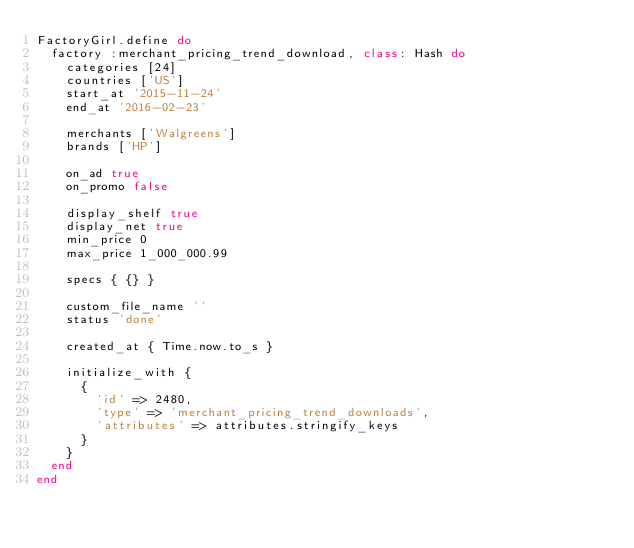Convert code to text. <code><loc_0><loc_0><loc_500><loc_500><_Ruby_>FactoryGirl.define do
  factory :merchant_pricing_trend_download, class: Hash do
    categories [24]
    countries ['US']
    start_at '2015-11-24'
    end_at '2016-02-23'

    merchants ['Walgreens']
    brands ['HP']

    on_ad true
    on_promo false

    display_shelf true
    display_net true
    min_price 0
    max_price 1_000_000.99

    specs { {} }

    custom_file_name ''
    status 'done'

    created_at { Time.now.to_s }

    initialize_with {
      {
        'id' => 2480,
        'type' => 'merchant_pricing_trend_downloads',
        'attributes' => attributes.stringify_keys
      }
    }
  end
end
</code> 